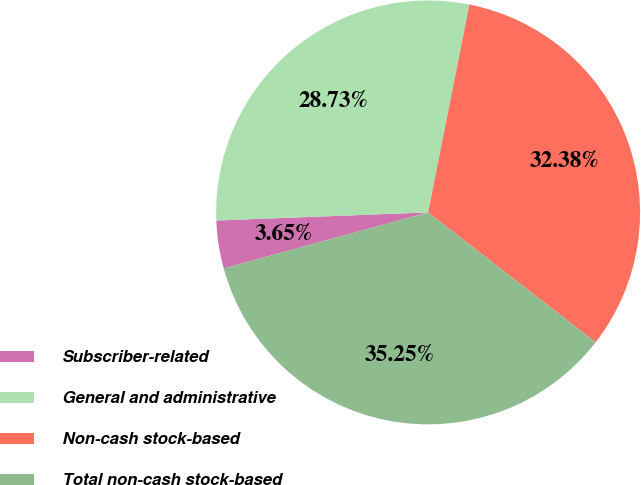Convert chart to OTSL. <chart><loc_0><loc_0><loc_500><loc_500><pie_chart><fcel>Subscriber-related<fcel>General and administrative<fcel>Non-cash stock-based<fcel>Total non-cash stock-based<nl><fcel>3.65%<fcel>28.73%<fcel>32.38%<fcel>35.25%<nl></chart> 